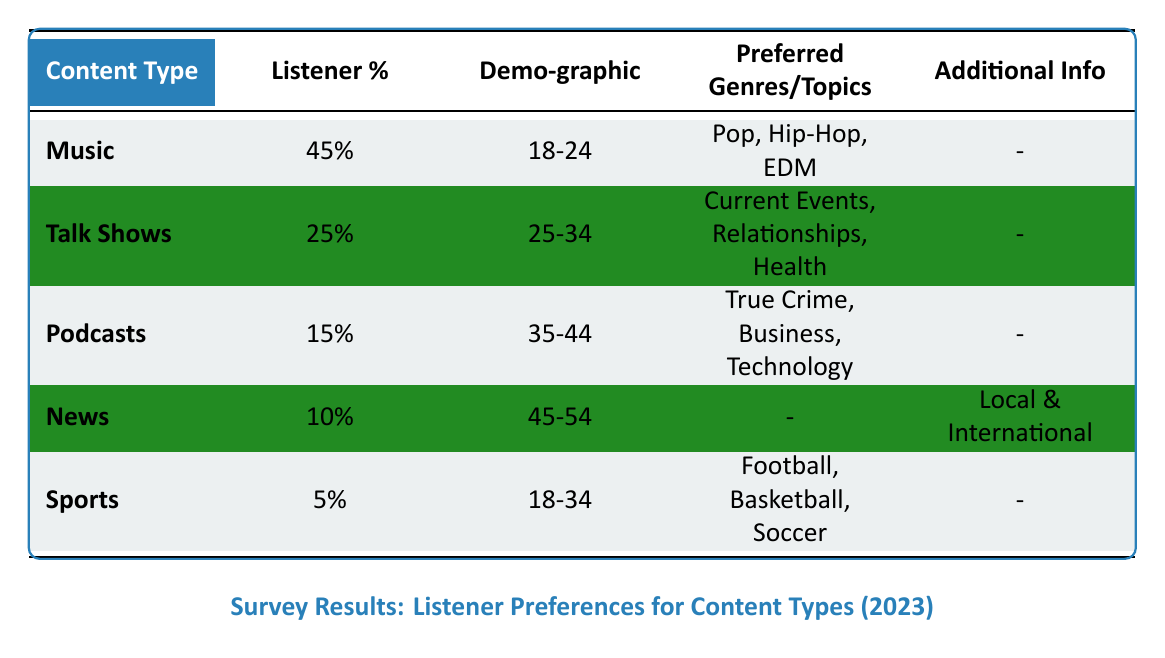What is the most preferred content type among listeners? The table lists the content types and their corresponding listener percentages. Music has the highest listener percentage at 45%.
Answer: Music What percentage of listeners prefer Talk Shows? The table indicates that the listener percentage for Talk Shows is 25%.
Answer: 25% Which demographic prefers Podcasts? According to the table, the demographic that prefers Podcasts is aged 35-44.
Answer: 35-44 How many preferred genres are listed for Music? The table shows that Music has three preferred genres: Pop, Hip-Hop, and EDM. Therefore, the count is three.
Answer: 3 Is News a more preferred content type than Sports according to the listener percentages? The table indicates that News has a listener percentage of 10%, while Sports has a listener percentage of 5%. Since 10% is greater than 5%, the answer is yes.
Answer: Yes What is the combined percentage of listeners who prefer Music and Talk Shows? The listener percentage for Music is 45% and for Talk Shows is 25%. Adding them together gives 45% + 25% = 70%.
Answer: 70% What percentage of listeners prefer Sports compared to those who prefer Podcasts? The table shows that Sports has a listener percentage of 5% and Podcasts have 15%. Therefore, the comparison indicates that 15% - 5% = 10%, meaning Podcasts are preferred by 10% more listeners than Sports.
Answer: 10% more Are there any preferred topics listed for News? According to the table, News does not have any preferred genres/topics listed, as indicated by the dash. Therefore, the answer is no.
Answer: No What is the average listener percentage for the content types in the table? To find the average, sum the listener percentages: 45 + 25 + 15 + 10 + 5 = 100. Divide this by the number of content types, which is 5. So, 100/5 = 20.
Answer: 20 